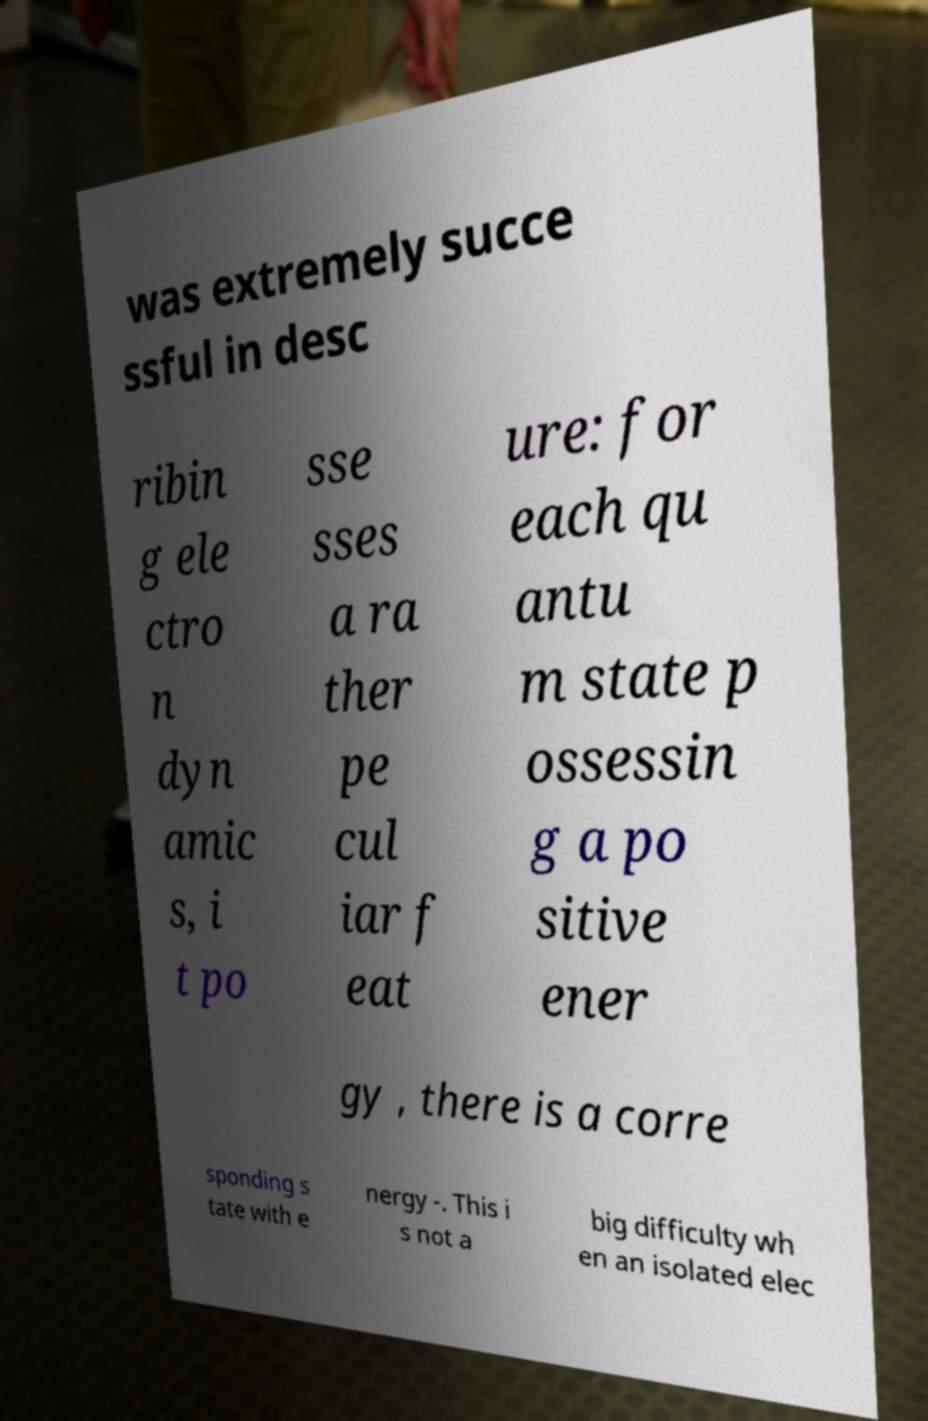What messages or text are displayed in this image? I need them in a readable, typed format. was extremely succe ssful in desc ribin g ele ctro n dyn amic s, i t po sse sses a ra ther pe cul iar f eat ure: for each qu antu m state p ossessin g a po sitive ener gy , there is a corre sponding s tate with e nergy -. This i s not a big difficulty wh en an isolated elec 